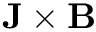<formula> <loc_0><loc_0><loc_500><loc_500>{ J } \times { B }</formula> 